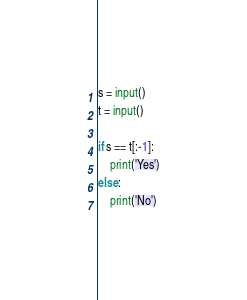Convert code to text. <code><loc_0><loc_0><loc_500><loc_500><_Python_>s = input()
t = input()

if s == t[:-1]:
    print('Yes')
else:
    print('No')
</code> 